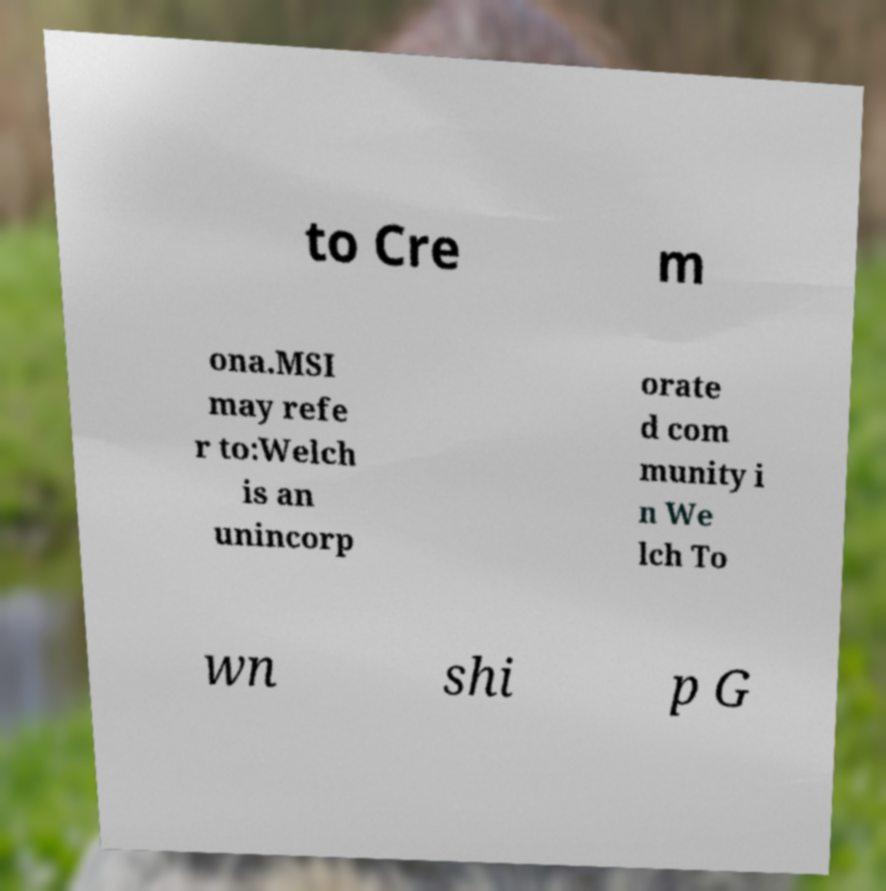Could you extract and type out the text from this image? to Cre m ona.MSI may refe r to:Welch is an unincorp orate d com munity i n We lch To wn shi p G 